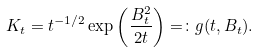Convert formula to latex. <formula><loc_0><loc_0><loc_500><loc_500>K _ { t } = t ^ { - 1 / 2 } \exp \left ( \frac { B _ { t } ^ { 2 } } { 2 t } \right ) = \colon g ( t , B _ { t } ) .</formula> 